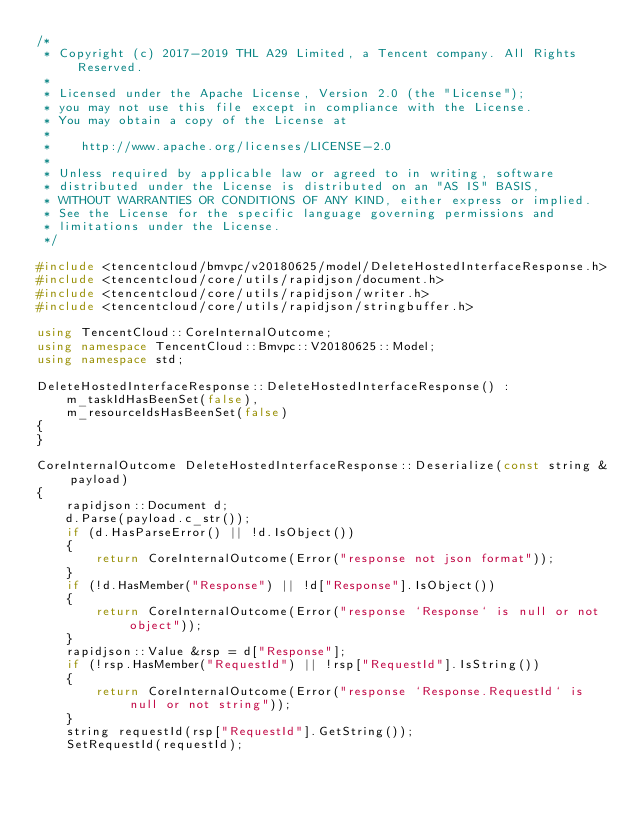<code> <loc_0><loc_0><loc_500><loc_500><_C++_>/*
 * Copyright (c) 2017-2019 THL A29 Limited, a Tencent company. All Rights Reserved.
 *
 * Licensed under the Apache License, Version 2.0 (the "License");
 * you may not use this file except in compliance with the License.
 * You may obtain a copy of the License at
 *
 *    http://www.apache.org/licenses/LICENSE-2.0
 *
 * Unless required by applicable law or agreed to in writing, software
 * distributed under the License is distributed on an "AS IS" BASIS,
 * WITHOUT WARRANTIES OR CONDITIONS OF ANY KIND, either express or implied.
 * See the License for the specific language governing permissions and
 * limitations under the License.
 */

#include <tencentcloud/bmvpc/v20180625/model/DeleteHostedInterfaceResponse.h>
#include <tencentcloud/core/utils/rapidjson/document.h>
#include <tencentcloud/core/utils/rapidjson/writer.h>
#include <tencentcloud/core/utils/rapidjson/stringbuffer.h>

using TencentCloud::CoreInternalOutcome;
using namespace TencentCloud::Bmvpc::V20180625::Model;
using namespace std;

DeleteHostedInterfaceResponse::DeleteHostedInterfaceResponse() :
    m_taskIdHasBeenSet(false),
    m_resourceIdsHasBeenSet(false)
{
}

CoreInternalOutcome DeleteHostedInterfaceResponse::Deserialize(const string &payload)
{
    rapidjson::Document d;
    d.Parse(payload.c_str());
    if (d.HasParseError() || !d.IsObject())
    {
        return CoreInternalOutcome(Error("response not json format"));
    }
    if (!d.HasMember("Response") || !d["Response"].IsObject())
    {
        return CoreInternalOutcome(Error("response `Response` is null or not object"));
    }
    rapidjson::Value &rsp = d["Response"];
    if (!rsp.HasMember("RequestId") || !rsp["RequestId"].IsString())
    {
        return CoreInternalOutcome(Error("response `Response.RequestId` is null or not string"));
    }
    string requestId(rsp["RequestId"].GetString());
    SetRequestId(requestId);
</code> 